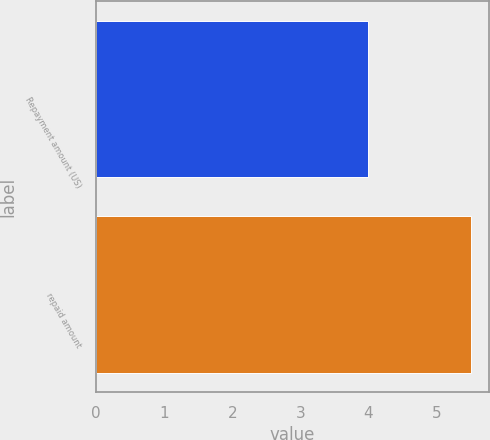<chart> <loc_0><loc_0><loc_500><loc_500><bar_chart><fcel>Repayment amount (US)<fcel>repaid amount<nl><fcel>4<fcel>5.5<nl></chart> 